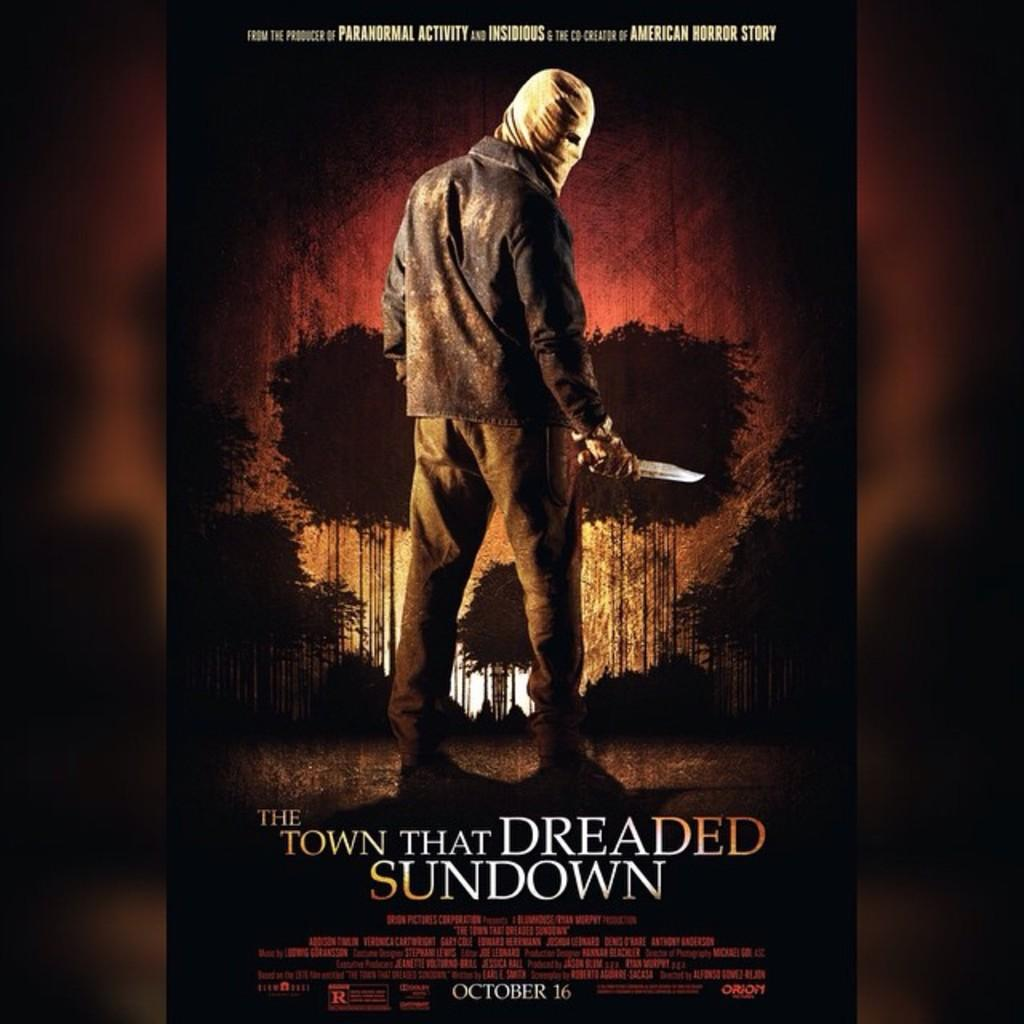<image>
Share a concise interpretation of the image provided. a movie box for the town that dreaded sundown has a man with a knofe 